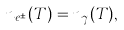Convert formula to latex. <formula><loc_0><loc_0><loc_500><loc_500>n _ { e ^ { \pm } } ( T ) = n _ { \gamma } ( T ) ,</formula> 